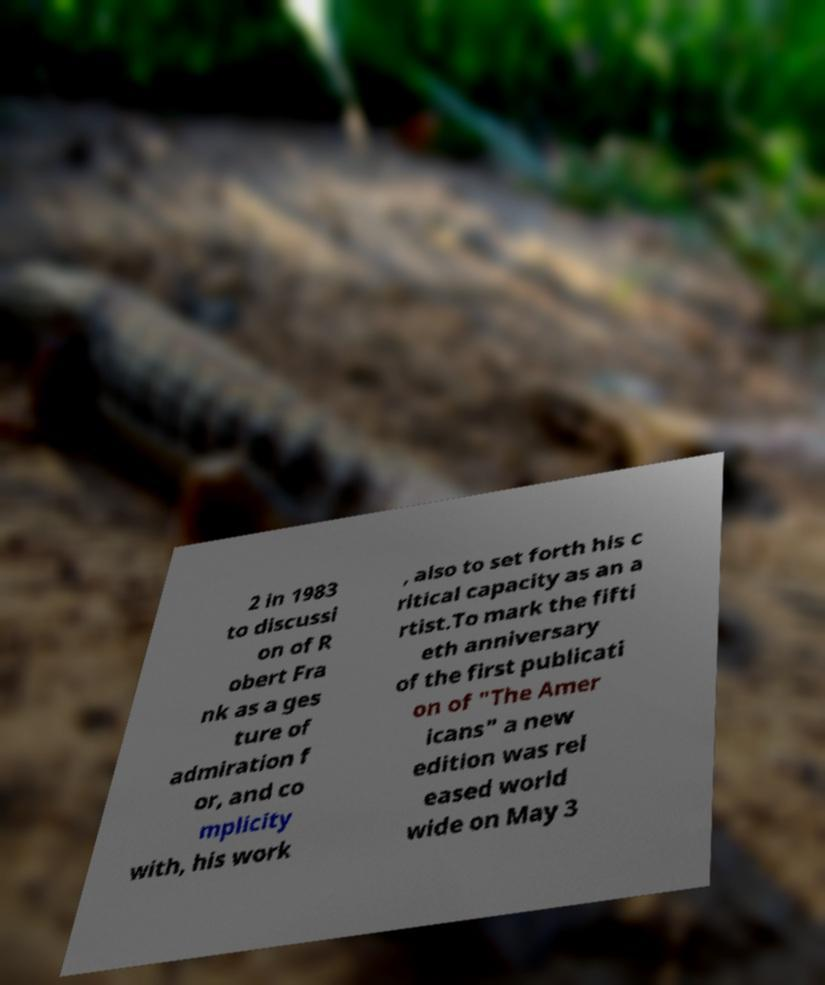Please identify and transcribe the text found in this image. 2 in 1983 to discussi on of R obert Fra nk as a ges ture of admiration f or, and co mplicity with, his work , also to set forth his c ritical capacity as an a rtist.To mark the fifti eth anniversary of the first publicati on of "The Amer icans" a new edition was rel eased world wide on May 3 